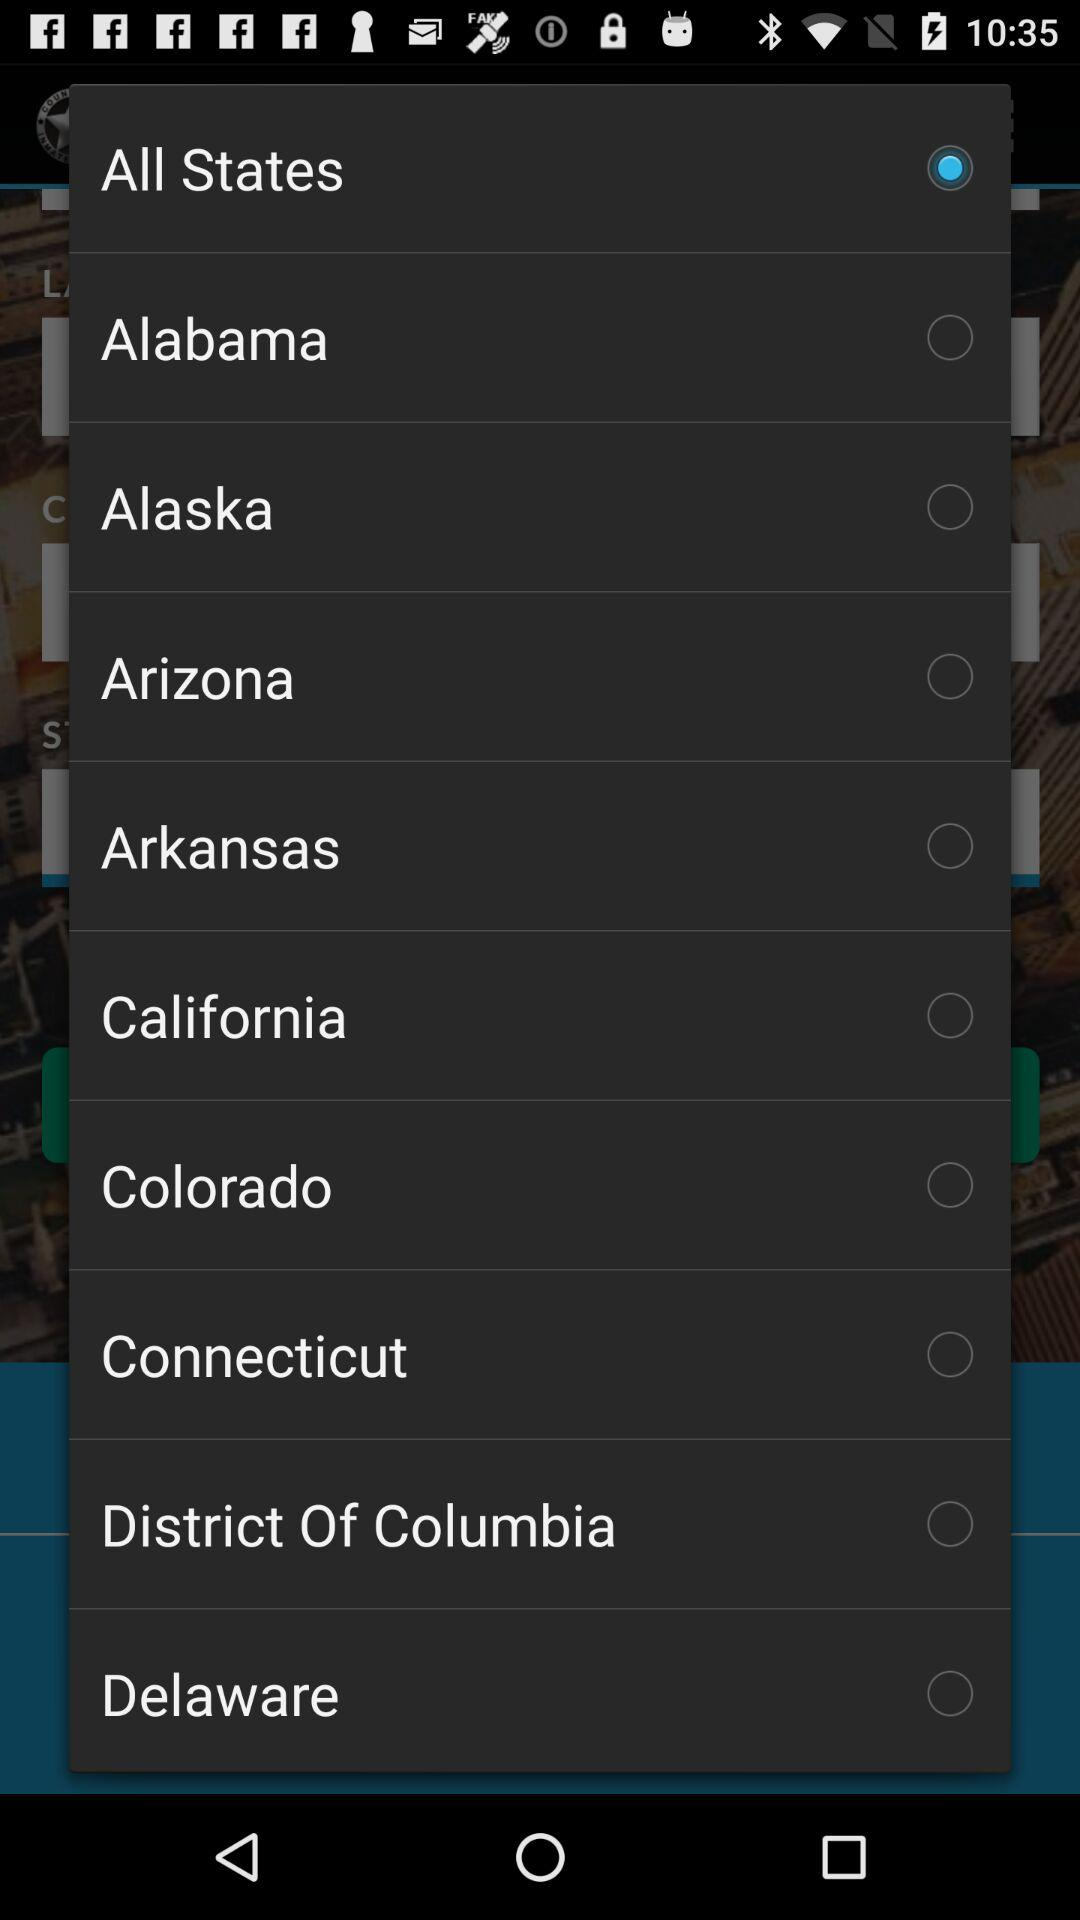Which option has been selected? The option that has been selected is "All States". 